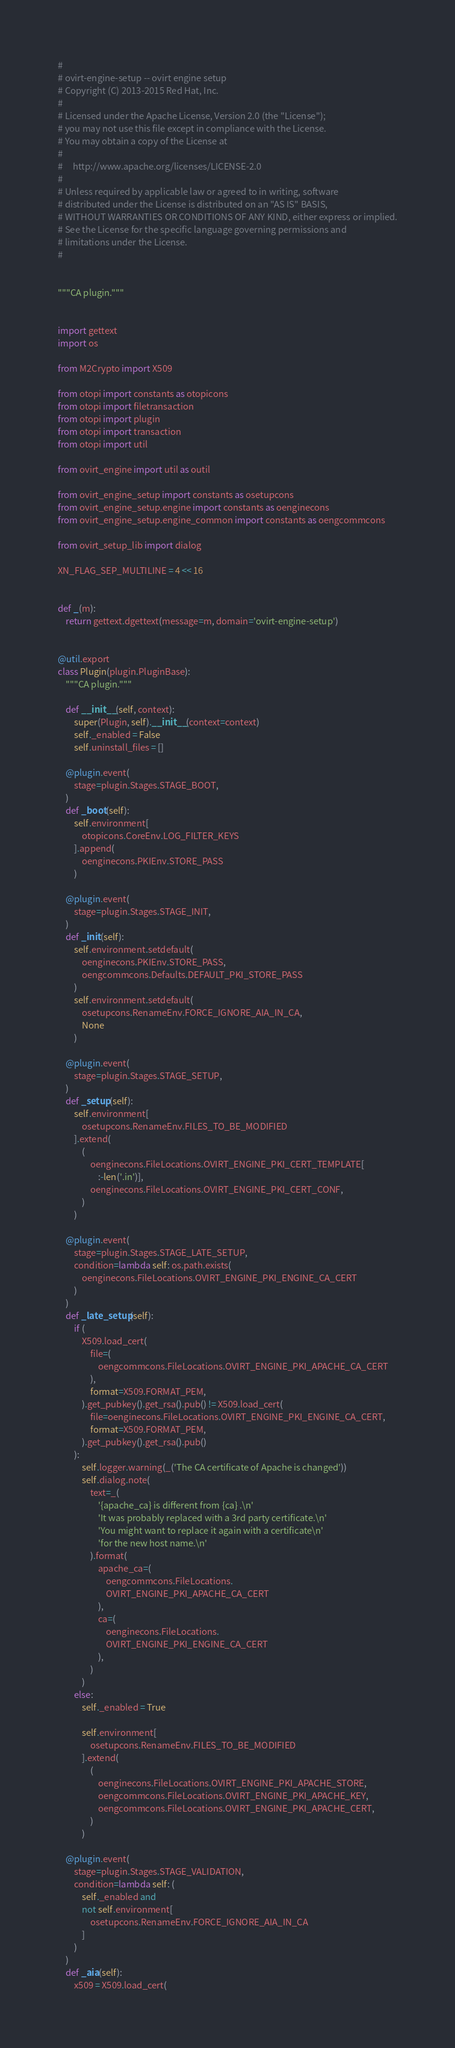Convert code to text. <code><loc_0><loc_0><loc_500><loc_500><_Python_>#
# ovirt-engine-setup -- ovirt engine setup
# Copyright (C) 2013-2015 Red Hat, Inc.
#
# Licensed under the Apache License, Version 2.0 (the "License");
# you may not use this file except in compliance with the License.
# You may obtain a copy of the License at
#
#     http://www.apache.org/licenses/LICENSE-2.0
#
# Unless required by applicable law or agreed to in writing, software
# distributed under the License is distributed on an "AS IS" BASIS,
# WITHOUT WARRANTIES OR CONDITIONS OF ANY KIND, either express or implied.
# See the License for the specific language governing permissions and
# limitations under the License.
#


"""CA plugin."""


import gettext
import os

from M2Crypto import X509

from otopi import constants as otopicons
from otopi import filetransaction
from otopi import plugin
from otopi import transaction
from otopi import util

from ovirt_engine import util as outil

from ovirt_engine_setup import constants as osetupcons
from ovirt_engine_setup.engine import constants as oenginecons
from ovirt_engine_setup.engine_common import constants as oengcommcons

from ovirt_setup_lib import dialog

XN_FLAG_SEP_MULTILINE = 4 << 16


def _(m):
    return gettext.dgettext(message=m, domain='ovirt-engine-setup')


@util.export
class Plugin(plugin.PluginBase):
    """CA plugin."""

    def __init__(self, context):
        super(Plugin, self).__init__(context=context)
        self._enabled = False
        self.uninstall_files = []

    @plugin.event(
        stage=plugin.Stages.STAGE_BOOT,
    )
    def _boot(self):
        self.environment[
            otopicons.CoreEnv.LOG_FILTER_KEYS
        ].append(
            oenginecons.PKIEnv.STORE_PASS
        )

    @plugin.event(
        stage=plugin.Stages.STAGE_INIT,
    )
    def _init(self):
        self.environment.setdefault(
            oenginecons.PKIEnv.STORE_PASS,
            oengcommcons.Defaults.DEFAULT_PKI_STORE_PASS
        )
        self.environment.setdefault(
            osetupcons.RenameEnv.FORCE_IGNORE_AIA_IN_CA,
            None
        )

    @plugin.event(
        stage=plugin.Stages.STAGE_SETUP,
    )
    def _setup(self):
        self.environment[
            osetupcons.RenameEnv.FILES_TO_BE_MODIFIED
        ].extend(
            (
                oenginecons.FileLocations.OVIRT_ENGINE_PKI_CERT_TEMPLATE[
                    :-len('.in')],
                oenginecons.FileLocations.OVIRT_ENGINE_PKI_CERT_CONF,
            )
        )

    @plugin.event(
        stage=plugin.Stages.STAGE_LATE_SETUP,
        condition=lambda self: os.path.exists(
            oenginecons.FileLocations.OVIRT_ENGINE_PKI_ENGINE_CA_CERT
        )
    )
    def _late_setup(self):
        if (
            X509.load_cert(
                file=(
                    oengcommcons.FileLocations.OVIRT_ENGINE_PKI_APACHE_CA_CERT
                ),
                format=X509.FORMAT_PEM,
            ).get_pubkey().get_rsa().pub() != X509.load_cert(
                file=oenginecons.FileLocations.OVIRT_ENGINE_PKI_ENGINE_CA_CERT,
                format=X509.FORMAT_PEM,
            ).get_pubkey().get_rsa().pub()
        ):
            self.logger.warning(_('The CA certificate of Apache is changed'))
            self.dialog.note(
                text=_(
                    '{apache_ca} is different from {ca} .\n'
                    'It was probably replaced with a 3rd party certificate.\n'
                    'You might want to replace it again with a certificate\n'
                    'for the new host name.\n'
                ).format(
                    apache_ca=(
                        oengcommcons.FileLocations.
                        OVIRT_ENGINE_PKI_APACHE_CA_CERT
                    ),
                    ca=(
                        oenginecons.FileLocations.
                        OVIRT_ENGINE_PKI_ENGINE_CA_CERT
                    ),
                )
            )
        else:
            self._enabled = True

            self.environment[
                osetupcons.RenameEnv.FILES_TO_BE_MODIFIED
            ].extend(
                (
                    oenginecons.FileLocations.OVIRT_ENGINE_PKI_APACHE_STORE,
                    oengcommcons.FileLocations.OVIRT_ENGINE_PKI_APACHE_KEY,
                    oengcommcons.FileLocations.OVIRT_ENGINE_PKI_APACHE_CERT,
                )
            )

    @plugin.event(
        stage=plugin.Stages.STAGE_VALIDATION,
        condition=lambda self: (
            self._enabled and
            not self.environment[
                osetupcons.RenameEnv.FORCE_IGNORE_AIA_IN_CA
            ]
        )
    )
    def _aia(self):
        x509 = X509.load_cert(</code> 